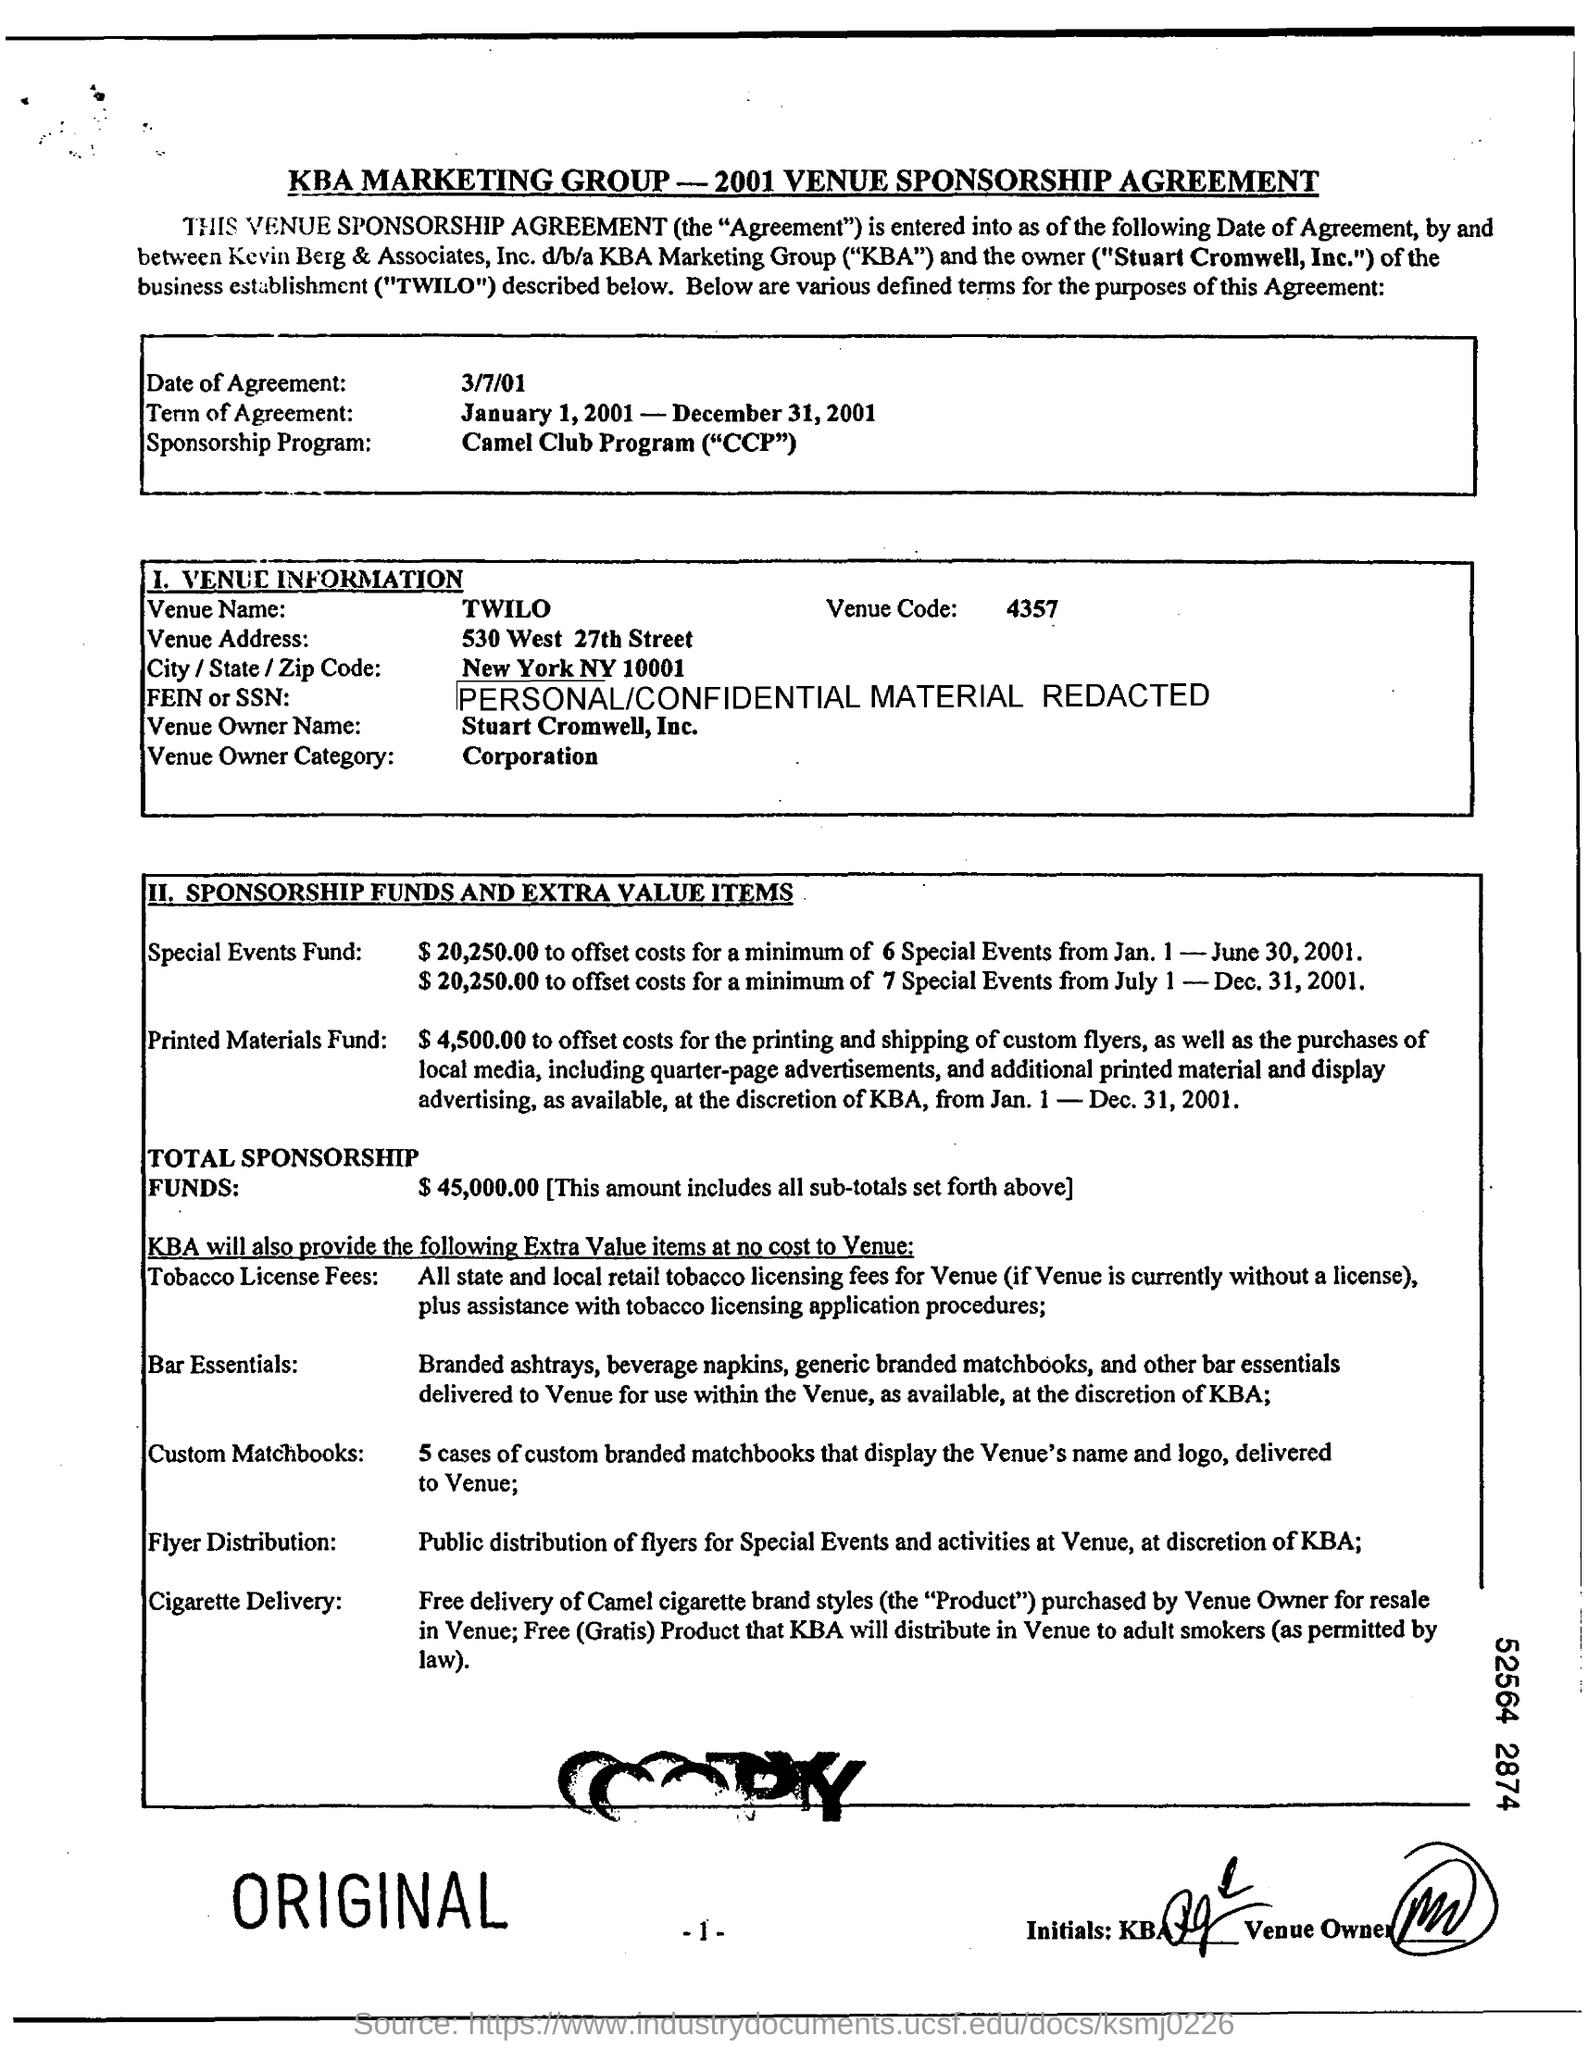Are there any terms related to product distribution or advertising? Yes, the agreement includes terms for flyer distribution of special events and free delivery of Camel cigarette brand styles within the venue, which KBA will distribute to adult smokers as permitted by law. 